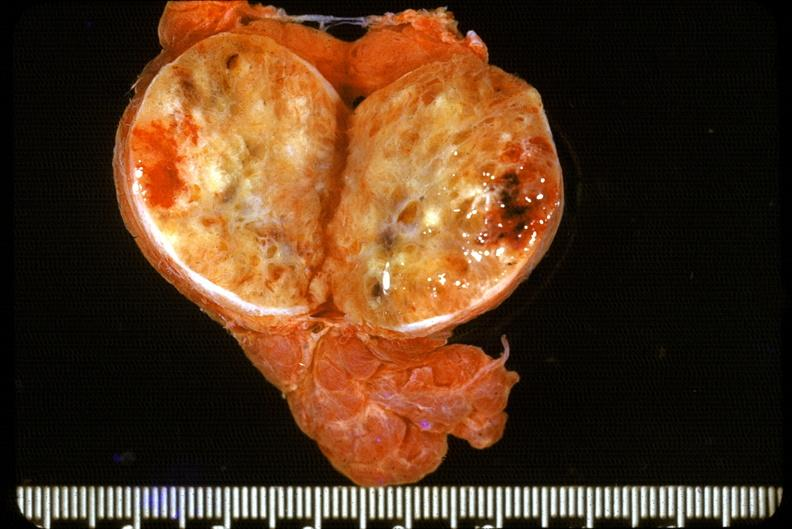what does this image show?
Answer the question using a single word or phrase. Thyroid 